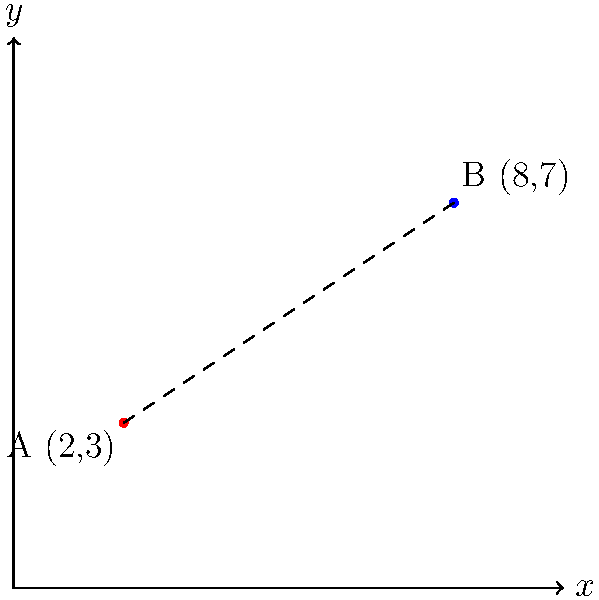On a map representing locations of civil rights violations, two incidents are marked at points A(2,3) and B(8,7). Using the distance formula, calculate the distance between these two points to determine the geographical spread of these violations. Round your answer to two decimal places. To find the distance between two points, we use the distance formula:

$$d = \sqrt{(x_2 - x_1)^2 + (y_2 - y_1)^2}$$

Where $(x_1, y_1)$ represents the coordinates of the first point and $(x_2, y_2)$ represents the coordinates of the second point.

Given:
Point A: $(2, 3)$
Point B: $(8, 7)$

Step 1: Identify the coordinates
$x_1 = 2$, $y_1 = 3$
$x_2 = 8$, $y_2 = 7$

Step 2: Substitute the values into the distance formula
$$d = \sqrt{(8 - 2)^2 + (7 - 3)^2}$$

Step 3: Simplify the expressions inside the parentheses
$$d = \sqrt{6^2 + 4^2}$$

Step 4: Calculate the squares
$$d = \sqrt{36 + 16}$$

Step 5: Add the values under the square root
$$d = \sqrt{52}$$

Step 6: Simplify the square root
$$d \approx 7.21110255$$

Step 7: Round to two decimal places
$$d \approx 7.21$$

Therefore, the distance between the two points representing civil rights violations is approximately 7.21 units on the map.
Answer: 7.21 units 